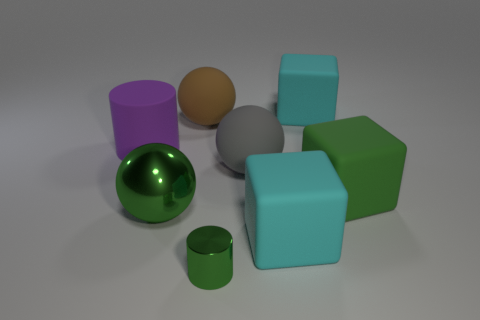Is the small shiny cylinder the same color as the large metallic sphere?
Provide a short and direct response. Yes. Are there an equal number of large brown objects that are on the left side of the big brown matte thing and purple things?
Ensure brevity in your answer.  No. What shape is the green object that is both behind the small green shiny object and right of the large green sphere?
Provide a short and direct response. Cube. Do the shiny sphere and the green shiny cylinder have the same size?
Provide a succinct answer. No. Is there a brown cylinder that has the same material as the small green cylinder?
Offer a terse response. No. What is the size of the ball that is the same color as the shiny cylinder?
Provide a short and direct response. Large. How many things are in front of the gray thing and on the right side of the green metal cylinder?
Offer a terse response. 2. There is a large green object that is right of the green cylinder; what is it made of?
Provide a short and direct response. Rubber. What number of other rubber cylinders have the same color as the large matte cylinder?
Your answer should be very brief. 0. The green object that is made of the same material as the green sphere is what size?
Offer a very short reply. Small. 